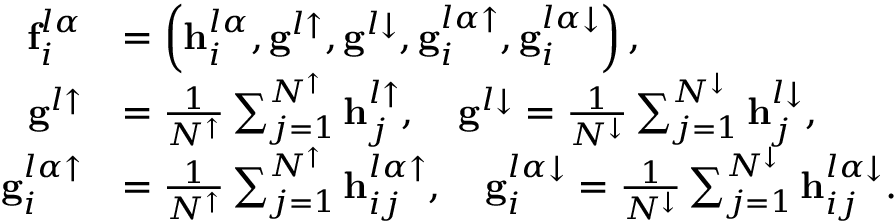Convert formula to latex. <formula><loc_0><loc_0><loc_500><loc_500>\begin{array} { r l } { f _ { i } ^ { l \alpha } } & { = \left ( h _ { i } ^ { l \alpha } , g ^ { l \uparrow } , g ^ { l \downarrow } , g _ { i } ^ { l \alpha \uparrow } , g _ { i } ^ { l \alpha \downarrow } \right ) , } \\ { g ^ { l \uparrow } } & { = \frac { 1 } { N ^ { \uparrow } } \sum _ { j = 1 } ^ { N ^ { \uparrow } } h _ { j } ^ { l \uparrow } , \quad g ^ { l \downarrow } = \frac { 1 } { N ^ { \downarrow } } \sum _ { j = 1 } ^ { N ^ { \downarrow } } h _ { j } ^ { l \downarrow } , } \\ { g _ { i } ^ { l \alpha \uparrow } } & { = \frac { 1 } { N ^ { \uparrow } } \sum _ { j = 1 } ^ { N ^ { \uparrow } } h _ { i j } ^ { l \alpha \uparrow } , \quad g _ { i } ^ { l \alpha \downarrow } = \frac { 1 } { N ^ { \downarrow } } \sum _ { j = 1 } ^ { N ^ { \downarrow } } h _ { i j } ^ { l \alpha \downarrow } . } \end{array}</formula> 